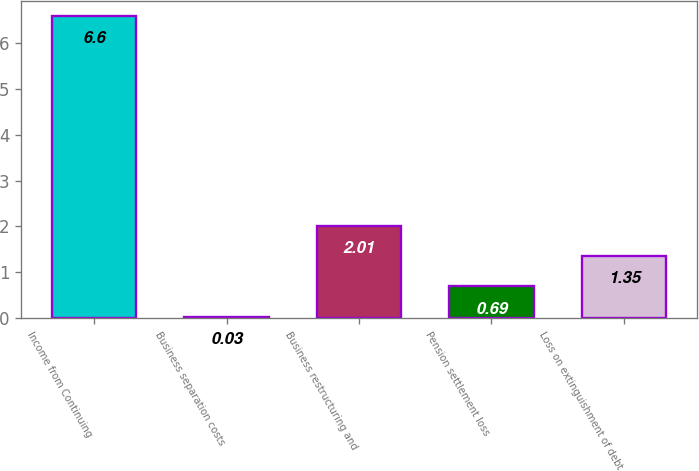<chart> <loc_0><loc_0><loc_500><loc_500><bar_chart><fcel>Income from Continuing<fcel>Business separation costs<fcel>Business restructuring and<fcel>Pension settlement loss<fcel>Loss on extinguishment of debt<nl><fcel>6.6<fcel>0.03<fcel>2.01<fcel>0.69<fcel>1.35<nl></chart> 